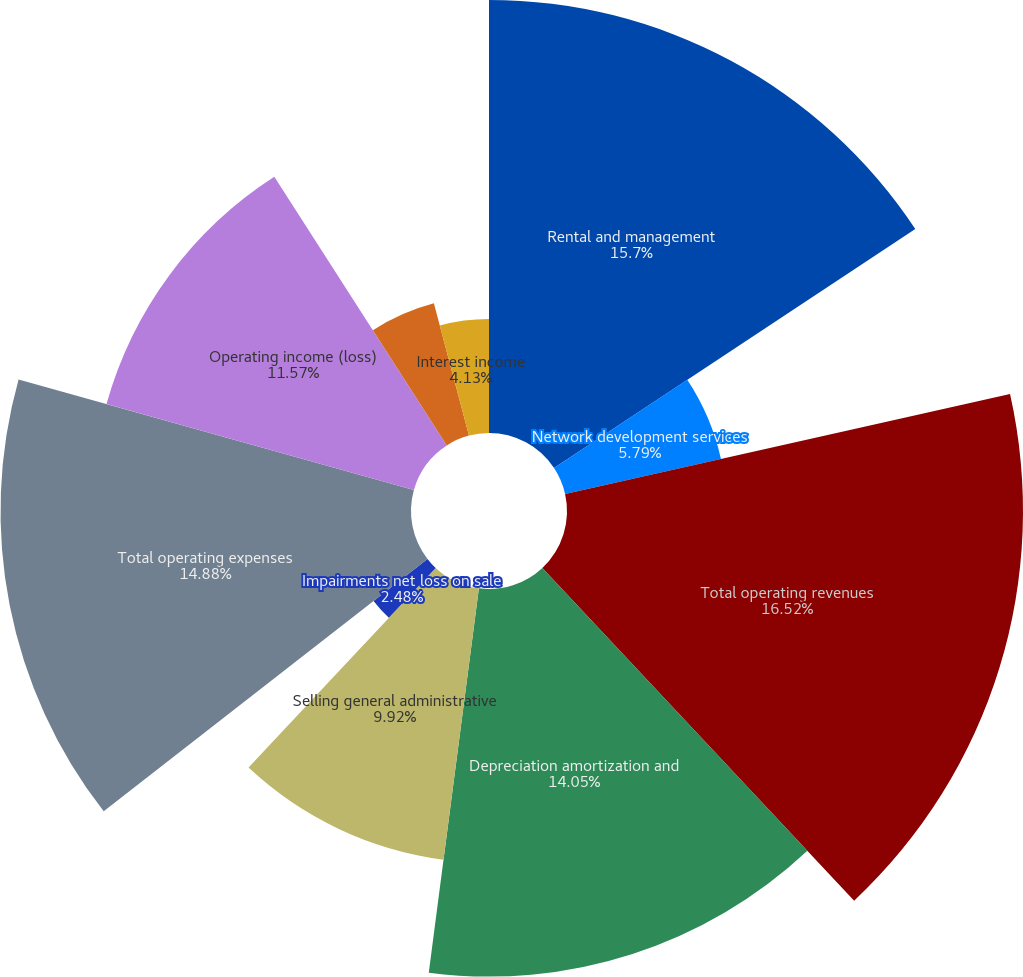Convert chart. <chart><loc_0><loc_0><loc_500><loc_500><pie_chart><fcel>Rental and management<fcel>Network development services<fcel>Total operating revenues<fcel>Depreciation amortization and<fcel>Selling general administrative<fcel>Impairments net loss on sale<fcel>Total operating expenses<fcel>Operating income (loss)<fcel>Interest income TV Azteca net<fcel>Interest income<nl><fcel>15.7%<fcel>5.79%<fcel>16.53%<fcel>14.05%<fcel>9.92%<fcel>2.48%<fcel>14.88%<fcel>11.57%<fcel>4.96%<fcel>4.13%<nl></chart> 